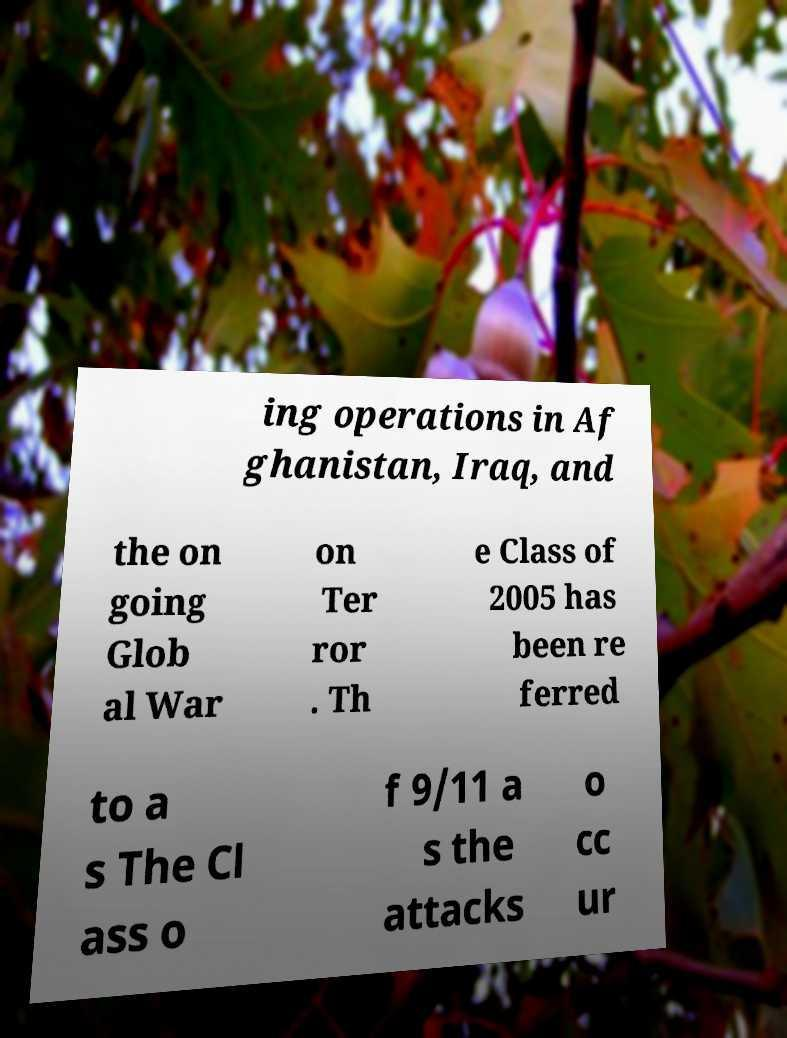For documentation purposes, I need the text within this image transcribed. Could you provide that? ing operations in Af ghanistan, Iraq, and the on going Glob al War on Ter ror . Th e Class of 2005 has been re ferred to a s The Cl ass o f 9/11 a s the attacks o cc ur 